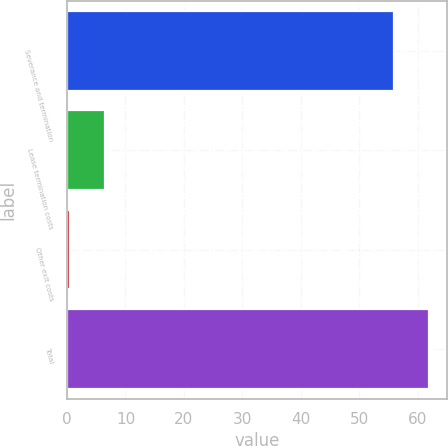Convert chart. <chart><loc_0><loc_0><loc_500><loc_500><bar_chart><fcel>Severance and termination<fcel>Lease termination costs<fcel>Other exit costs<fcel>Total<nl><fcel>55.9<fcel>6.57<fcel>0.5<fcel>61.97<nl></chart> 